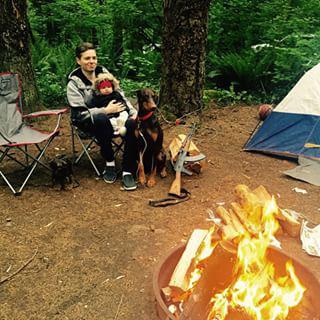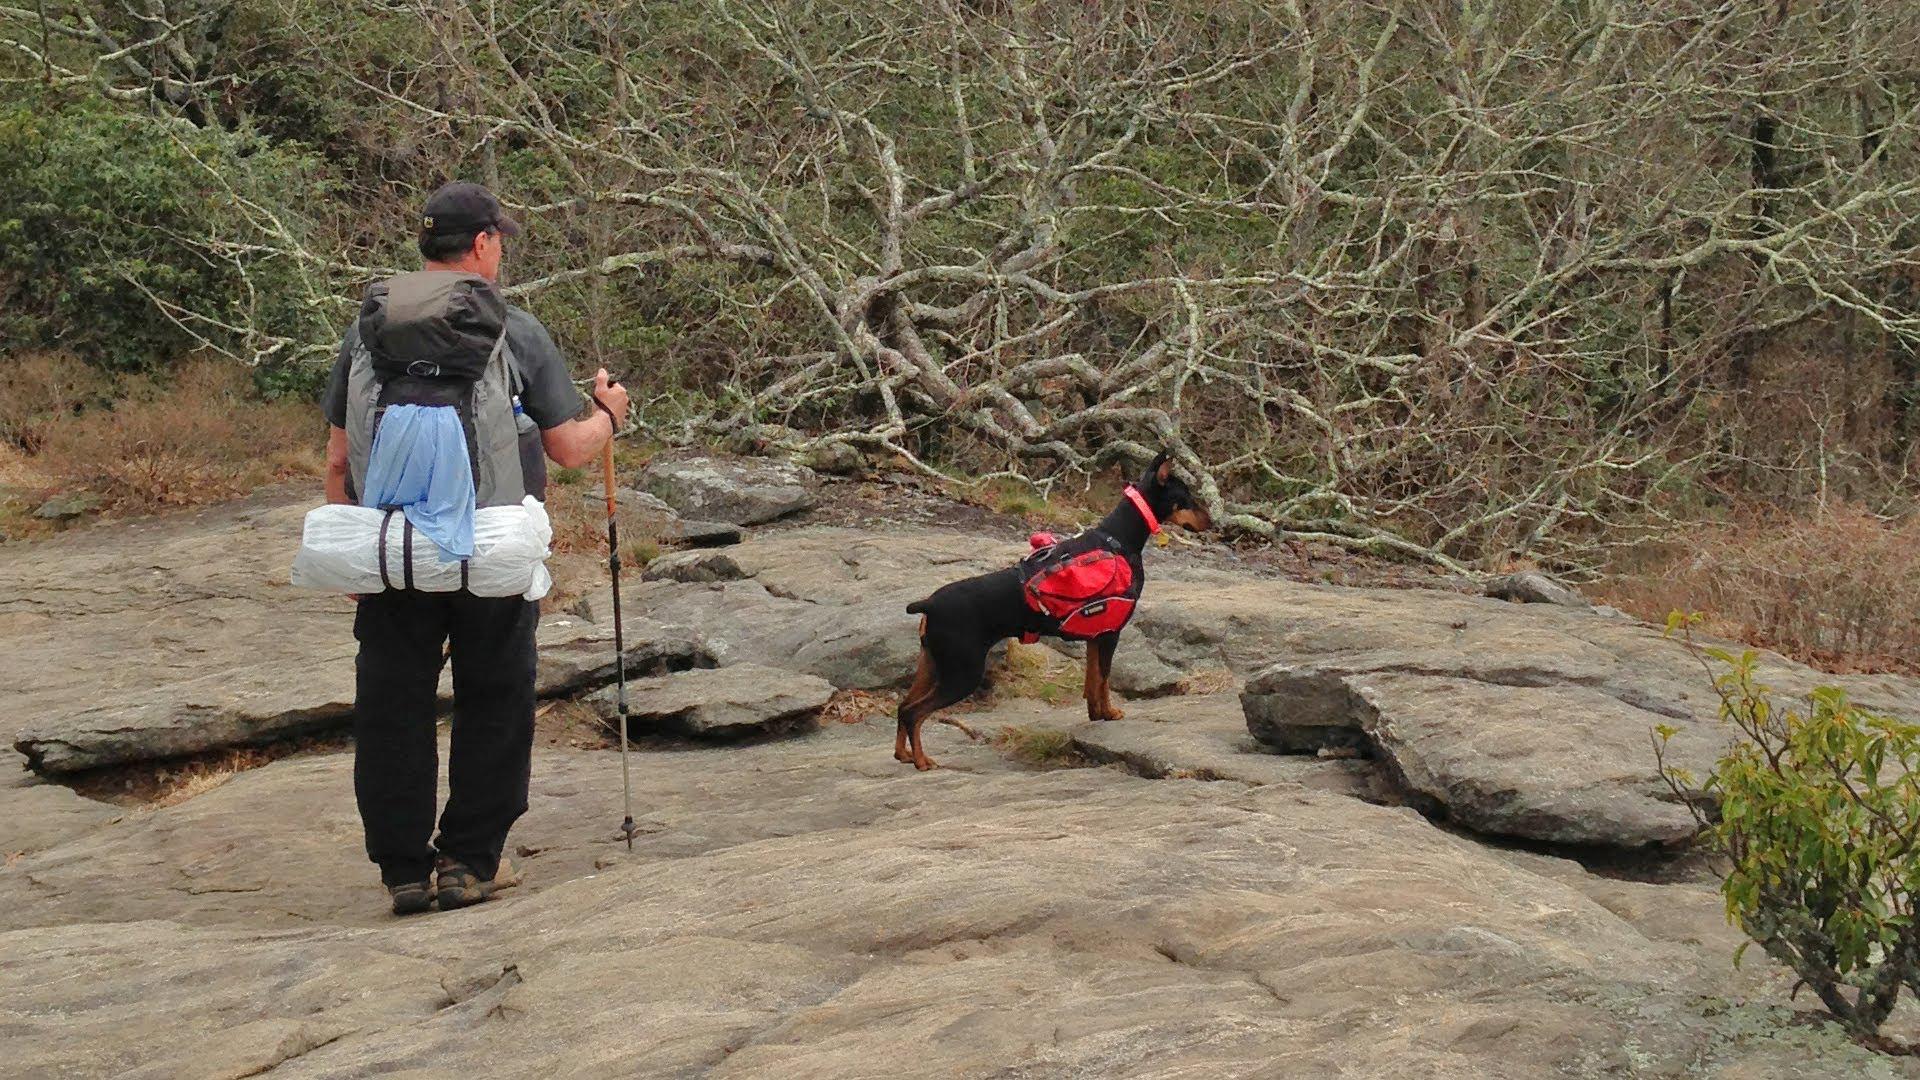The first image is the image on the left, the second image is the image on the right. Given the left and right images, does the statement "A dog is laying on a blanket." hold true? Answer yes or no. No. 